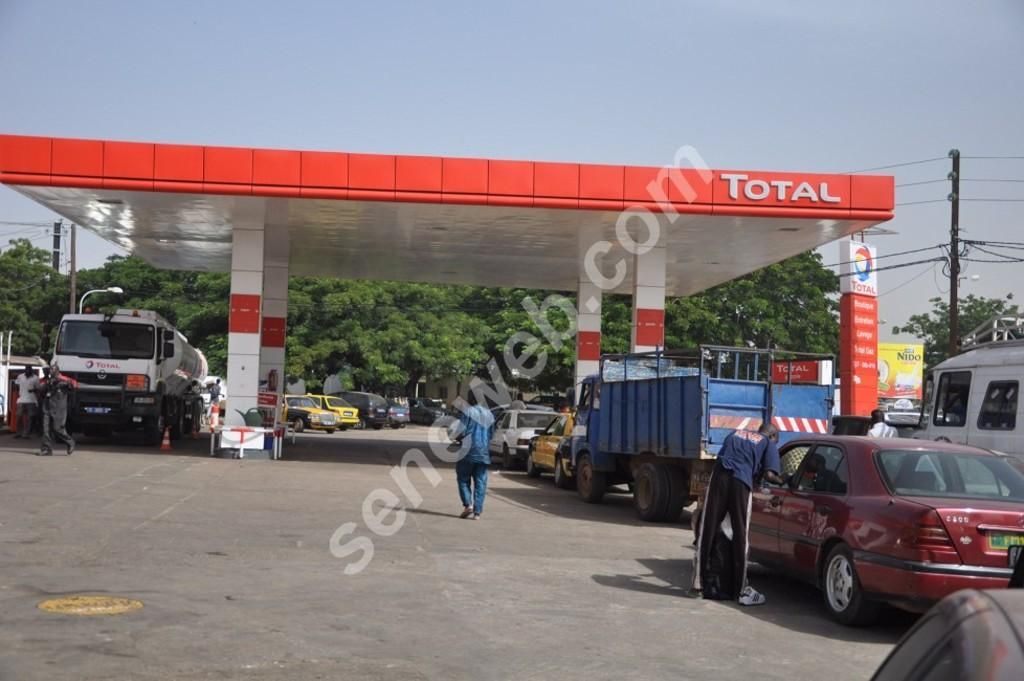<image>
Share a concise interpretation of the image provided. The overhang of a gas station says the word "Total" on it. 